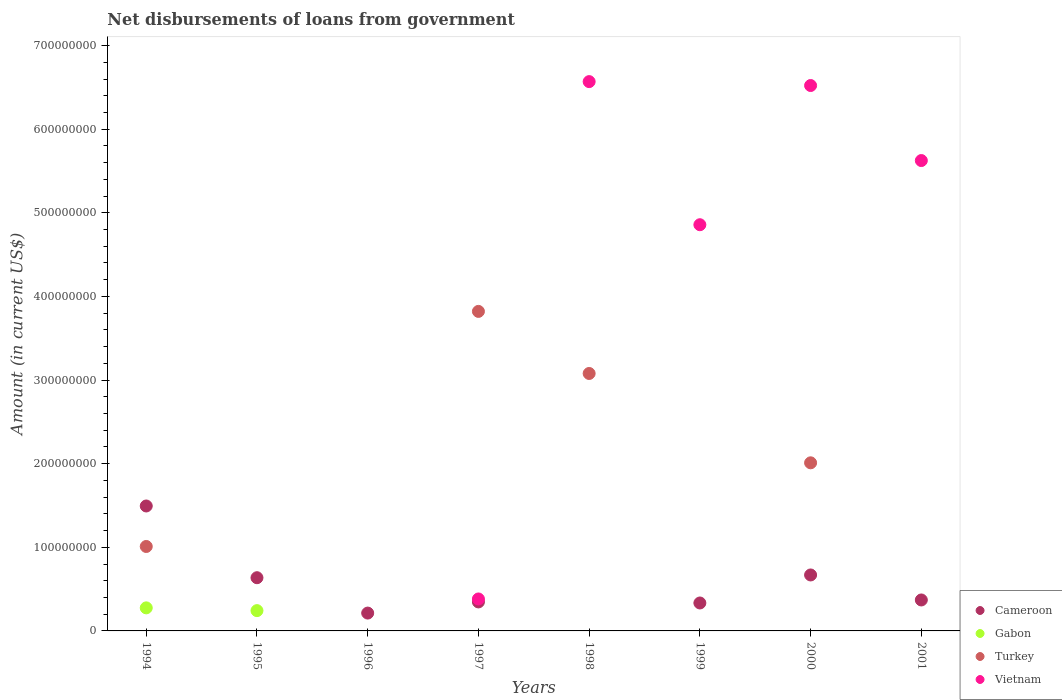How many different coloured dotlines are there?
Provide a short and direct response. 4. What is the amount of loan disbursed from government in Cameroon in 1999?
Ensure brevity in your answer.  3.34e+07. Across all years, what is the maximum amount of loan disbursed from government in Gabon?
Give a very brief answer. 2.76e+07. What is the total amount of loan disbursed from government in Vietnam in the graph?
Give a very brief answer. 2.40e+09. What is the difference between the amount of loan disbursed from government in Cameroon in 1994 and that in 2000?
Your answer should be very brief. 8.25e+07. What is the average amount of loan disbursed from government in Vietnam per year?
Your answer should be compact. 2.99e+08. In the year 1994, what is the difference between the amount of loan disbursed from government in Turkey and amount of loan disbursed from government in Gabon?
Make the answer very short. 7.34e+07. In how many years, is the amount of loan disbursed from government in Cameroon greater than 40000000 US$?
Give a very brief answer. 3. Is the amount of loan disbursed from government in Vietnam in 1997 less than that in 1998?
Offer a very short reply. Yes. What is the difference between the highest and the second highest amount of loan disbursed from government in Turkey?
Offer a terse response. 7.42e+07. What is the difference between the highest and the lowest amount of loan disbursed from government in Turkey?
Offer a very short reply. 3.82e+08. Is the sum of the amount of loan disbursed from government in Cameroon in 1996 and 2000 greater than the maximum amount of loan disbursed from government in Gabon across all years?
Offer a terse response. Yes. Does the amount of loan disbursed from government in Vietnam monotonically increase over the years?
Your response must be concise. No. Is the amount of loan disbursed from government in Cameroon strictly greater than the amount of loan disbursed from government in Vietnam over the years?
Provide a succinct answer. No. Is the amount of loan disbursed from government in Cameroon strictly less than the amount of loan disbursed from government in Vietnam over the years?
Make the answer very short. No. How many dotlines are there?
Provide a succinct answer. 4. What is the difference between two consecutive major ticks on the Y-axis?
Your answer should be very brief. 1.00e+08. Does the graph contain grids?
Your answer should be compact. No. How many legend labels are there?
Your answer should be very brief. 4. What is the title of the graph?
Offer a very short reply. Net disbursements of loans from government. What is the Amount (in current US$) of Cameroon in 1994?
Give a very brief answer. 1.49e+08. What is the Amount (in current US$) of Gabon in 1994?
Offer a very short reply. 2.76e+07. What is the Amount (in current US$) in Turkey in 1994?
Provide a succinct answer. 1.01e+08. What is the Amount (in current US$) in Vietnam in 1994?
Offer a very short reply. 0. What is the Amount (in current US$) in Cameroon in 1995?
Provide a succinct answer. 6.36e+07. What is the Amount (in current US$) of Gabon in 1995?
Give a very brief answer. 2.43e+07. What is the Amount (in current US$) of Turkey in 1995?
Offer a very short reply. 0. What is the Amount (in current US$) of Vietnam in 1995?
Give a very brief answer. 0. What is the Amount (in current US$) in Cameroon in 1996?
Keep it short and to the point. 2.13e+07. What is the Amount (in current US$) of Turkey in 1996?
Your answer should be very brief. 0. What is the Amount (in current US$) of Vietnam in 1996?
Your answer should be very brief. 0. What is the Amount (in current US$) of Cameroon in 1997?
Your answer should be compact. 3.47e+07. What is the Amount (in current US$) of Gabon in 1997?
Keep it short and to the point. 0. What is the Amount (in current US$) in Turkey in 1997?
Ensure brevity in your answer.  3.82e+08. What is the Amount (in current US$) of Vietnam in 1997?
Your response must be concise. 3.82e+07. What is the Amount (in current US$) of Cameroon in 1998?
Give a very brief answer. 0. What is the Amount (in current US$) in Turkey in 1998?
Offer a very short reply. 3.08e+08. What is the Amount (in current US$) of Vietnam in 1998?
Give a very brief answer. 6.57e+08. What is the Amount (in current US$) in Cameroon in 1999?
Offer a very short reply. 3.34e+07. What is the Amount (in current US$) of Turkey in 1999?
Offer a terse response. 0. What is the Amount (in current US$) of Vietnam in 1999?
Keep it short and to the point. 4.86e+08. What is the Amount (in current US$) in Cameroon in 2000?
Your answer should be compact. 6.69e+07. What is the Amount (in current US$) of Turkey in 2000?
Ensure brevity in your answer.  2.01e+08. What is the Amount (in current US$) of Vietnam in 2000?
Give a very brief answer. 6.52e+08. What is the Amount (in current US$) in Cameroon in 2001?
Your response must be concise. 3.70e+07. What is the Amount (in current US$) in Turkey in 2001?
Provide a succinct answer. 0. What is the Amount (in current US$) of Vietnam in 2001?
Offer a very short reply. 5.62e+08. Across all years, what is the maximum Amount (in current US$) of Cameroon?
Provide a short and direct response. 1.49e+08. Across all years, what is the maximum Amount (in current US$) of Gabon?
Ensure brevity in your answer.  2.76e+07. Across all years, what is the maximum Amount (in current US$) of Turkey?
Make the answer very short. 3.82e+08. Across all years, what is the maximum Amount (in current US$) of Vietnam?
Your answer should be very brief. 6.57e+08. Across all years, what is the minimum Amount (in current US$) of Cameroon?
Provide a succinct answer. 0. Across all years, what is the minimum Amount (in current US$) of Gabon?
Your answer should be very brief. 0. Across all years, what is the minimum Amount (in current US$) of Vietnam?
Your answer should be compact. 0. What is the total Amount (in current US$) in Cameroon in the graph?
Provide a short and direct response. 4.06e+08. What is the total Amount (in current US$) in Gabon in the graph?
Provide a short and direct response. 5.18e+07. What is the total Amount (in current US$) of Turkey in the graph?
Ensure brevity in your answer.  9.92e+08. What is the total Amount (in current US$) of Vietnam in the graph?
Offer a very short reply. 2.40e+09. What is the difference between the Amount (in current US$) of Cameroon in 1994 and that in 1995?
Keep it short and to the point. 8.58e+07. What is the difference between the Amount (in current US$) in Gabon in 1994 and that in 1995?
Your response must be concise. 3.30e+06. What is the difference between the Amount (in current US$) of Cameroon in 1994 and that in 1996?
Provide a short and direct response. 1.28e+08. What is the difference between the Amount (in current US$) in Cameroon in 1994 and that in 1997?
Provide a succinct answer. 1.15e+08. What is the difference between the Amount (in current US$) in Turkey in 1994 and that in 1997?
Your answer should be very brief. -2.81e+08. What is the difference between the Amount (in current US$) in Turkey in 1994 and that in 1998?
Keep it short and to the point. -2.07e+08. What is the difference between the Amount (in current US$) of Cameroon in 1994 and that in 1999?
Offer a terse response. 1.16e+08. What is the difference between the Amount (in current US$) in Cameroon in 1994 and that in 2000?
Your response must be concise. 8.25e+07. What is the difference between the Amount (in current US$) in Turkey in 1994 and that in 2000?
Your answer should be compact. -1.00e+08. What is the difference between the Amount (in current US$) of Cameroon in 1994 and that in 2001?
Your answer should be compact. 1.12e+08. What is the difference between the Amount (in current US$) in Cameroon in 1995 and that in 1996?
Keep it short and to the point. 4.23e+07. What is the difference between the Amount (in current US$) in Cameroon in 1995 and that in 1997?
Your response must be concise. 2.90e+07. What is the difference between the Amount (in current US$) of Cameroon in 1995 and that in 1999?
Give a very brief answer. 3.02e+07. What is the difference between the Amount (in current US$) in Cameroon in 1995 and that in 2000?
Provide a short and direct response. -3.29e+06. What is the difference between the Amount (in current US$) of Cameroon in 1995 and that in 2001?
Provide a succinct answer. 2.66e+07. What is the difference between the Amount (in current US$) in Cameroon in 1996 and that in 1997?
Provide a short and direct response. -1.33e+07. What is the difference between the Amount (in current US$) in Cameroon in 1996 and that in 1999?
Keep it short and to the point. -1.21e+07. What is the difference between the Amount (in current US$) in Cameroon in 1996 and that in 2000?
Your response must be concise. -4.56e+07. What is the difference between the Amount (in current US$) in Cameroon in 1996 and that in 2001?
Keep it short and to the point. -1.57e+07. What is the difference between the Amount (in current US$) in Turkey in 1997 and that in 1998?
Ensure brevity in your answer.  7.42e+07. What is the difference between the Amount (in current US$) of Vietnam in 1997 and that in 1998?
Your answer should be compact. -6.19e+08. What is the difference between the Amount (in current US$) in Cameroon in 1997 and that in 1999?
Your answer should be compact. 1.25e+06. What is the difference between the Amount (in current US$) of Vietnam in 1997 and that in 1999?
Your answer should be very brief. -4.48e+08. What is the difference between the Amount (in current US$) of Cameroon in 1997 and that in 2000?
Your answer should be compact. -3.23e+07. What is the difference between the Amount (in current US$) in Turkey in 1997 and that in 2000?
Ensure brevity in your answer.  1.81e+08. What is the difference between the Amount (in current US$) in Vietnam in 1997 and that in 2000?
Your answer should be very brief. -6.14e+08. What is the difference between the Amount (in current US$) of Cameroon in 1997 and that in 2001?
Make the answer very short. -2.36e+06. What is the difference between the Amount (in current US$) of Vietnam in 1997 and that in 2001?
Ensure brevity in your answer.  -5.24e+08. What is the difference between the Amount (in current US$) in Vietnam in 1998 and that in 1999?
Provide a succinct answer. 1.71e+08. What is the difference between the Amount (in current US$) of Turkey in 1998 and that in 2000?
Offer a terse response. 1.07e+08. What is the difference between the Amount (in current US$) in Vietnam in 1998 and that in 2000?
Your answer should be compact. 4.68e+06. What is the difference between the Amount (in current US$) in Vietnam in 1998 and that in 2001?
Offer a terse response. 9.44e+07. What is the difference between the Amount (in current US$) of Cameroon in 1999 and that in 2000?
Your answer should be compact. -3.35e+07. What is the difference between the Amount (in current US$) of Vietnam in 1999 and that in 2000?
Offer a terse response. -1.66e+08. What is the difference between the Amount (in current US$) in Cameroon in 1999 and that in 2001?
Offer a very short reply. -3.61e+06. What is the difference between the Amount (in current US$) in Vietnam in 1999 and that in 2001?
Provide a short and direct response. -7.67e+07. What is the difference between the Amount (in current US$) in Cameroon in 2000 and that in 2001?
Keep it short and to the point. 2.99e+07. What is the difference between the Amount (in current US$) of Vietnam in 2000 and that in 2001?
Provide a succinct answer. 8.97e+07. What is the difference between the Amount (in current US$) of Cameroon in 1994 and the Amount (in current US$) of Gabon in 1995?
Provide a short and direct response. 1.25e+08. What is the difference between the Amount (in current US$) of Cameroon in 1994 and the Amount (in current US$) of Turkey in 1997?
Your answer should be very brief. -2.33e+08. What is the difference between the Amount (in current US$) in Cameroon in 1994 and the Amount (in current US$) in Vietnam in 1997?
Provide a short and direct response. 1.11e+08. What is the difference between the Amount (in current US$) of Gabon in 1994 and the Amount (in current US$) of Turkey in 1997?
Keep it short and to the point. -3.55e+08. What is the difference between the Amount (in current US$) in Gabon in 1994 and the Amount (in current US$) in Vietnam in 1997?
Offer a very short reply. -1.06e+07. What is the difference between the Amount (in current US$) of Turkey in 1994 and the Amount (in current US$) of Vietnam in 1997?
Provide a short and direct response. 6.28e+07. What is the difference between the Amount (in current US$) of Cameroon in 1994 and the Amount (in current US$) of Turkey in 1998?
Your answer should be very brief. -1.58e+08. What is the difference between the Amount (in current US$) in Cameroon in 1994 and the Amount (in current US$) in Vietnam in 1998?
Ensure brevity in your answer.  -5.07e+08. What is the difference between the Amount (in current US$) in Gabon in 1994 and the Amount (in current US$) in Turkey in 1998?
Keep it short and to the point. -2.80e+08. What is the difference between the Amount (in current US$) of Gabon in 1994 and the Amount (in current US$) of Vietnam in 1998?
Your response must be concise. -6.29e+08. What is the difference between the Amount (in current US$) in Turkey in 1994 and the Amount (in current US$) in Vietnam in 1998?
Ensure brevity in your answer.  -5.56e+08. What is the difference between the Amount (in current US$) in Cameroon in 1994 and the Amount (in current US$) in Vietnam in 1999?
Ensure brevity in your answer.  -3.36e+08. What is the difference between the Amount (in current US$) in Gabon in 1994 and the Amount (in current US$) in Vietnam in 1999?
Your answer should be compact. -4.58e+08. What is the difference between the Amount (in current US$) in Turkey in 1994 and the Amount (in current US$) in Vietnam in 1999?
Provide a succinct answer. -3.85e+08. What is the difference between the Amount (in current US$) of Cameroon in 1994 and the Amount (in current US$) of Turkey in 2000?
Keep it short and to the point. -5.16e+07. What is the difference between the Amount (in current US$) in Cameroon in 1994 and the Amount (in current US$) in Vietnam in 2000?
Offer a terse response. -5.03e+08. What is the difference between the Amount (in current US$) of Gabon in 1994 and the Amount (in current US$) of Turkey in 2000?
Offer a terse response. -1.73e+08. What is the difference between the Amount (in current US$) in Gabon in 1994 and the Amount (in current US$) in Vietnam in 2000?
Your answer should be compact. -6.25e+08. What is the difference between the Amount (in current US$) of Turkey in 1994 and the Amount (in current US$) of Vietnam in 2000?
Your answer should be very brief. -5.51e+08. What is the difference between the Amount (in current US$) in Cameroon in 1994 and the Amount (in current US$) in Vietnam in 2001?
Your response must be concise. -4.13e+08. What is the difference between the Amount (in current US$) in Gabon in 1994 and the Amount (in current US$) in Vietnam in 2001?
Your answer should be compact. -5.35e+08. What is the difference between the Amount (in current US$) of Turkey in 1994 and the Amount (in current US$) of Vietnam in 2001?
Offer a terse response. -4.62e+08. What is the difference between the Amount (in current US$) in Cameroon in 1995 and the Amount (in current US$) in Turkey in 1997?
Ensure brevity in your answer.  -3.18e+08. What is the difference between the Amount (in current US$) of Cameroon in 1995 and the Amount (in current US$) of Vietnam in 1997?
Ensure brevity in your answer.  2.54e+07. What is the difference between the Amount (in current US$) in Gabon in 1995 and the Amount (in current US$) in Turkey in 1997?
Provide a short and direct response. -3.58e+08. What is the difference between the Amount (in current US$) in Gabon in 1995 and the Amount (in current US$) in Vietnam in 1997?
Offer a very short reply. -1.39e+07. What is the difference between the Amount (in current US$) in Cameroon in 1995 and the Amount (in current US$) in Turkey in 1998?
Offer a very short reply. -2.44e+08. What is the difference between the Amount (in current US$) in Cameroon in 1995 and the Amount (in current US$) in Vietnam in 1998?
Your answer should be very brief. -5.93e+08. What is the difference between the Amount (in current US$) in Gabon in 1995 and the Amount (in current US$) in Turkey in 1998?
Keep it short and to the point. -2.84e+08. What is the difference between the Amount (in current US$) in Gabon in 1995 and the Amount (in current US$) in Vietnam in 1998?
Offer a terse response. -6.33e+08. What is the difference between the Amount (in current US$) of Cameroon in 1995 and the Amount (in current US$) of Vietnam in 1999?
Offer a very short reply. -4.22e+08. What is the difference between the Amount (in current US$) in Gabon in 1995 and the Amount (in current US$) in Vietnam in 1999?
Offer a very short reply. -4.61e+08. What is the difference between the Amount (in current US$) in Cameroon in 1995 and the Amount (in current US$) in Turkey in 2000?
Offer a very short reply. -1.37e+08. What is the difference between the Amount (in current US$) in Cameroon in 1995 and the Amount (in current US$) in Vietnam in 2000?
Make the answer very short. -5.89e+08. What is the difference between the Amount (in current US$) of Gabon in 1995 and the Amount (in current US$) of Turkey in 2000?
Ensure brevity in your answer.  -1.77e+08. What is the difference between the Amount (in current US$) in Gabon in 1995 and the Amount (in current US$) in Vietnam in 2000?
Offer a terse response. -6.28e+08. What is the difference between the Amount (in current US$) of Cameroon in 1995 and the Amount (in current US$) of Vietnam in 2001?
Ensure brevity in your answer.  -4.99e+08. What is the difference between the Amount (in current US$) of Gabon in 1995 and the Amount (in current US$) of Vietnam in 2001?
Provide a short and direct response. -5.38e+08. What is the difference between the Amount (in current US$) of Cameroon in 1996 and the Amount (in current US$) of Turkey in 1997?
Ensure brevity in your answer.  -3.61e+08. What is the difference between the Amount (in current US$) in Cameroon in 1996 and the Amount (in current US$) in Vietnam in 1997?
Your answer should be compact. -1.69e+07. What is the difference between the Amount (in current US$) in Cameroon in 1996 and the Amount (in current US$) in Turkey in 1998?
Provide a short and direct response. -2.87e+08. What is the difference between the Amount (in current US$) in Cameroon in 1996 and the Amount (in current US$) in Vietnam in 1998?
Keep it short and to the point. -6.36e+08. What is the difference between the Amount (in current US$) in Cameroon in 1996 and the Amount (in current US$) in Vietnam in 1999?
Make the answer very short. -4.64e+08. What is the difference between the Amount (in current US$) of Cameroon in 1996 and the Amount (in current US$) of Turkey in 2000?
Provide a succinct answer. -1.80e+08. What is the difference between the Amount (in current US$) of Cameroon in 1996 and the Amount (in current US$) of Vietnam in 2000?
Your response must be concise. -6.31e+08. What is the difference between the Amount (in current US$) in Cameroon in 1996 and the Amount (in current US$) in Vietnam in 2001?
Provide a succinct answer. -5.41e+08. What is the difference between the Amount (in current US$) in Cameroon in 1997 and the Amount (in current US$) in Turkey in 1998?
Provide a succinct answer. -2.73e+08. What is the difference between the Amount (in current US$) of Cameroon in 1997 and the Amount (in current US$) of Vietnam in 1998?
Offer a very short reply. -6.22e+08. What is the difference between the Amount (in current US$) of Turkey in 1997 and the Amount (in current US$) of Vietnam in 1998?
Your response must be concise. -2.75e+08. What is the difference between the Amount (in current US$) in Cameroon in 1997 and the Amount (in current US$) in Vietnam in 1999?
Make the answer very short. -4.51e+08. What is the difference between the Amount (in current US$) in Turkey in 1997 and the Amount (in current US$) in Vietnam in 1999?
Provide a succinct answer. -1.04e+08. What is the difference between the Amount (in current US$) of Cameroon in 1997 and the Amount (in current US$) of Turkey in 2000?
Your response must be concise. -1.66e+08. What is the difference between the Amount (in current US$) of Cameroon in 1997 and the Amount (in current US$) of Vietnam in 2000?
Your answer should be compact. -6.18e+08. What is the difference between the Amount (in current US$) in Turkey in 1997 and the Amount (in current US$) in Vietnam in 2000?
Make the answer very short. -2.70e+08. What is the difference between the Amount (in current US$) of Cameroon in 1997 and the Amount (in current US$) of Vietnam in 2001?
Your answer should be very brief. -5.28e+08. What is the difference between the Amount (in current US$) of Turkey in 1997 and the Amount (in current US$) of Vietnam in 2001?
Provide a succinct answer. -1.80e+08. What is the difference between the Amount (in current US$) in Turkey in 1998 and the Amount (in current US$) in Vietnam in 1999?
Your answer should be very brief. -1.78e+08. What is the difference between the Amount (in current US$) in Turkey in 1998 and the Amount (in current US$) in Vietnam in 2000?
Make the answer very short. -3.44e+08. What is the difference between the Amount (in current US$) of Turkey in 1998 and the Amount (in current US$) of Vietnam in 2001?
Your answer should be compact. -2.55e+08. What is the difference between the Amount (in current US$) of Cameroon in 1999 and the Amount (in current US$) of Turkey in 2000?
Offer a very short reply. -1.68e+08. What is the difference between the Amount (in current US$) of Cameroon in 1999 and the Amount (in current US$) of Vietnam in 2000?
Your response must be concise. -6.19e+08. What is the difference between the Amount (in current US$) in Cameroon in 1999 and the Amount (in current US$) in Vietnam in 2001?
Your answer should be compact. -5.29e+08. What is the difference between the Amount (in current US$) of Cameroon in 2000 and the Amount (in current US$) of Vietnam in 2001?
Ensure brevity in your answer.  -4.96e+08. What is the difference between the Amount (in current US$) in Turkey in 2000 and the Amount (in current US$) in Vietnam in 2001?
Make the answer very short. -3.61e+08. What is the average Amount (in current US$) in Cameroon per year?
Provide a succinct answer. 5.08e+07. What is the average Amount (in current US$) in Gabon per year?
Keep it short and to the point. 6.48e+06. What is the average Amount (in current US$) in Turkey per year?
Give a very brief answer. 1.24e+08. What is the average Amount (in current US$) in Vietnam per year?
Ensure brevity in your answer.  2.99e+08. In the year 1994, what is the difference between the Amount (in current US$) in Cameroon and Amount (in current US$) in Gabon?
Provide a short and direct response. 1.22e+08. In the year 1994, what is the difference between the Amount (in current US$) in Cameroon and Amount (in current US$) in Turkey?
Provide a succinct answer. 4.84e+07. In the year 1994, what is the difference between the Amount (in current US$) in Gabon and Amount (in current US$) in Turkey?
Your answer should be very brief. -7.34e+07. In the year 1995, what is the difference between the Amount (in current US$) of Cameroon and Amount (in current US$) of Gabon?
Give a very brief answer. 3.94e+07. In the year 1997, what is the difference between the Amount (in current US$) of Cameroon and Amount (in current US$) of Turkey?
Ensure brevity in your answer.  -3.47e+08. In the year 1997, what is the difference between the Amount (in current US$) in Cameroon and Amount (in current US$) in Vietnam?
Make the answer very short. -3.55e+06. In the year 1997, what is the difference between the Amount (in current US$) in Turkey and Amount (in current US$) in Vietnam?
Your response must be concise. 3.44e+08. In the year 1998, what is the difference between the Amount (in current US$) of Turkey and Amount (in current US$) of Vietnam?
Give a very brief answer. -3.49e+08. In the year 1999, what is the difference between the Amount (in current US$) of Cameroon and Amount (in current US$) of Vietnam?
Provide a succinct answer. -4.52e+08. In the year 2000, what is the difference between the Amount (in current US$) of Cameroon and Amount (in current US$) of Turkey?
Provide a short and direct response. -1.34e+08. In the year 2000, what is the difference between the Amount (in current US$) in Cameroon and Amount (in current US$) in Vietnam?
Make the answer very short. -5.85e+08. In the year 2000, what is the difference between the Amount (in current US$) of Turkey and Amount (in current US$) of Vietnam?
Offer a very short reply. -4.51e+08. In the year 2001, what is the difference between the Amount (in current US$) of Cameroon and Amount (in current US$) of Vietnam?
Ensure brevity in your answer.  -5.25e+08. What is the ratio of the Amount (in current US$) in Cameroon in 1994 to that in 1995?
Offer a very short reply. 2.35. What is the ratio of the Amount (in current US$) of Gabon in 1994 to that in 1995?
Keep it short and to the point. 1.14. What is the ratio of the Amount (in current US$) in Cameroon in 1994 to that in 1996?
Ensure brevity in your answer.  7. What is the ratio of the Amount (in current US$) in Cameroon in 1994 to that in 1997?
Give a very brief answer. 4.31. What is the ratio of the Amount (in current US$) of Turkey in 1994 to that in 1997?
Ensure brevity in your answer.  0.26. What is the ratio of the Amount (in current US$) in Turkey in 1994 to that in 1998?
Keep it short and to the point. 0.33. What is the ratio of the Amount (in current US$) in Cameroon in 1994 to that in 1999?
Your response must be concise. 4.47. What is the ratio of the Amount (in current US$) of Cameroon in 1994 to that in 2000?
Your answer should be very brief. 2.23. What is the ratio of the Amount (in current US$) in Turkey in 1994 to that in 2000?
Make the answer very short. 0.5. What is the ratio of the Amount (in current US$) of Cameroon in 1994 to that in 2001?
Offer a very short reply. 4.04. What is the ratio of the Amount (in current US$) of Cameroon in 1995 to that in 1996?
Provide a short and direct response. 2.98. What is the ratio of the Amount (in current US$) of Cameroon in 1995 to that in 1997?
Keep it short and to the point. 1.84. What is the ratio of the Amount (in current US$) in Cameroon in 1995 to that in 1999?
Make the answer very short. 1.9. What is the ratio of the Amount (in current US$) in Cameroon in 1995 to that in 2000?
Your response must be concise. 0.95. What is the ratio of the Amount (in current US$) of Cameroon in 1995 to that in 2001?
Offer a terse response. 1.72. What is the ratio of the Amount (in current US$) in Cameroon in 1996 to that in 1997?
Ensure brevity in your answer.  0.62. What is the ratio of the Amount (in current US$) of Cameroon in 1996 to that in 1999?
Your answer should be compact. 0.64. What is the ratio of the Amount (in current US$) in Cameroon in 1996 to that in 2000?
Provide a succinct answer. 0.32. What is the ratio of the Amount (in current US$) in Cameroon in 1996 to that in 2001?
Ensure brevity in your answer.  0.58. What is the ratio of the Amount (in current US$) in Turkey in 1997 to that in 1998?
Ensure brevity in your answer.  1.24. What is the ratio of the Amount (in current US$) in Vietnam in 1997 to that in 1998?
Provide a succinct answer. 0.06. What is the ratio of the Amount (in current US$) of Cameroon in 1997 to that in 1999?
Offer a very short reply. 1.04. What is the ratio of the Amount (in current US$) in Vietnam in 1997 to that in 1999?
Your answer should be very brief. 0.08. What is the ratio of the Amount (in current US$) of Cameroon in 1997 to that in 2000?
Your answer should be compact. 0.52. What is the ratio of the Amount (in current US$) of Turkey in 1997 to that in 2000?
Your answer should be very brief. 1.9. What is the ratio of the Amount (in current US$) in Vietnam in 1997 to that in 2000?
Your answer should be compact. 0.06. What is the ratio of the Amount (in current US$) in Cameroon in 1997 to that in 2001?
Your answer should be compact. 0.94. What is the ratio of the Amount (in current US$) in Vietnam in 1997 to that in 2001?
Keep it short and to the point. 0.07. What is the ratio of the Amount (in current US$) of Vietnam in 1998 to that in 1999?
Your answer should be compact. 1.35. What is the ratio of the Amount (in current US$) in Turkey in 1998 to that in 2000?
Give a very brief answer. 1.53. What is the ratio of the Amount (in current US$) of Vietnam in 1998 to that in 2001?
Your response must be concise. 1.17. What is the ratio of the Amount (in current US$) of Cameroon in 1999 to that in 2000?
Your answer should be very brief. 0.5. What is the ratio of the Amount (in current US$) in Vietnam in 1999 to that in 2000?
Your response must be concise. 0.74. What is the ratio of the Amount (in current US$) in Cameroon in 1999 to that in 2001?
Provide a short and direct response. 0.9. What is the ratio of the Amount (in current US$) in Vietnam in 1999 to that in 2001?
Provide a short and direct response. 0.86. What is the ratio of the Amount (in current US$) of Cameroon in 2000 to that in 2001?
Keep it short and to the point. 1.81. What is the ratio of the Amount (in current US$) of Vietnam in 2000 to that in 2001?
Offer a terse response. 1.16. What is the difference between the highest and the second highest Amount (in current US$) in Cameroon?
Give a very brief answer. 8.25e+07. What is the difference between the highest and the second highest Amount (in current US$) in Turkey?
Keep it short and to the point. 7.42e+07. What is the difference between the highest and the second highest Amount (in current US$) of Vietnam?
Provide a short and direct response. 4.68e+06. What is the difference between the highest and the lowest Amount (in current US$) of Cameroon?
Your answer should be compact. 1.49e+08. What is the difference between the highest and the lowest Amount (in current US$) of Gabon?
Your response must be concise. 2.76e+07. What is the difference between the highest and the lowest Amount (in current US$) of Turkey?
Offer a very short reply. 3.82e+08. What is the difference between the highest and the lowest Amount (in current US$) of Vietnam?
Your answer should be very brief. 6.57e+08. 